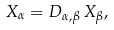Convert formula to latex. <formula><loc_0><loc_0><loc_500><loc_500>X _ { \alpha } = D _ { \alpha , \beta } \, X _ { \beta } ,</formula> 